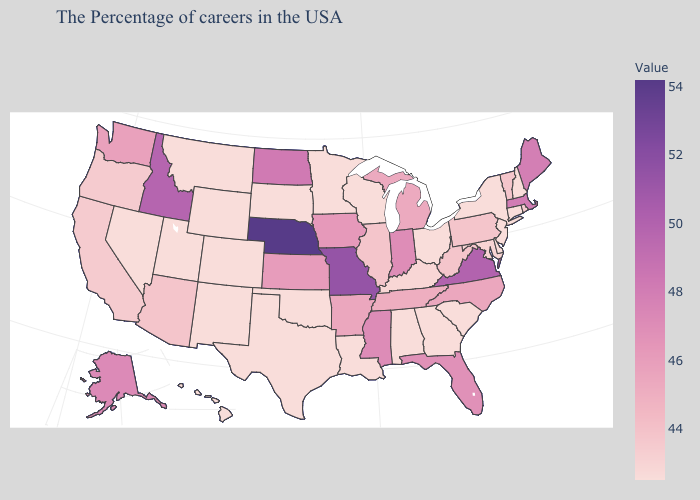Does Connecticut have the highest value in the USA?
Be succinct. No. Which states hav the highest value in the South?
Answer briefly. Virginia. Which states have the lowest value in the MidWest?
Keep it brief. Ohio, Wisconsin, Minnesota, South Dakota. Among the states that border Michigan , which have the lowest value?
Answer briefly. Ohio, Wisconsin. Among the states that border Mississippi , which have the highest value?
Keep it brief. Arkansas. Which states hav the highest value in the Northeast?
Give a very brief answer. Massachusetts. Does New Jersey have a higher value than Michigan?
Answer briefly. No. Among the states that border Tennessee , does Kentucky have the lowest value?
Answer briefly. No. Among the states that border Pennsylvania , which have the lowest value?
Concise answer only. New York, New Jersey, Delaware, Ohio. 